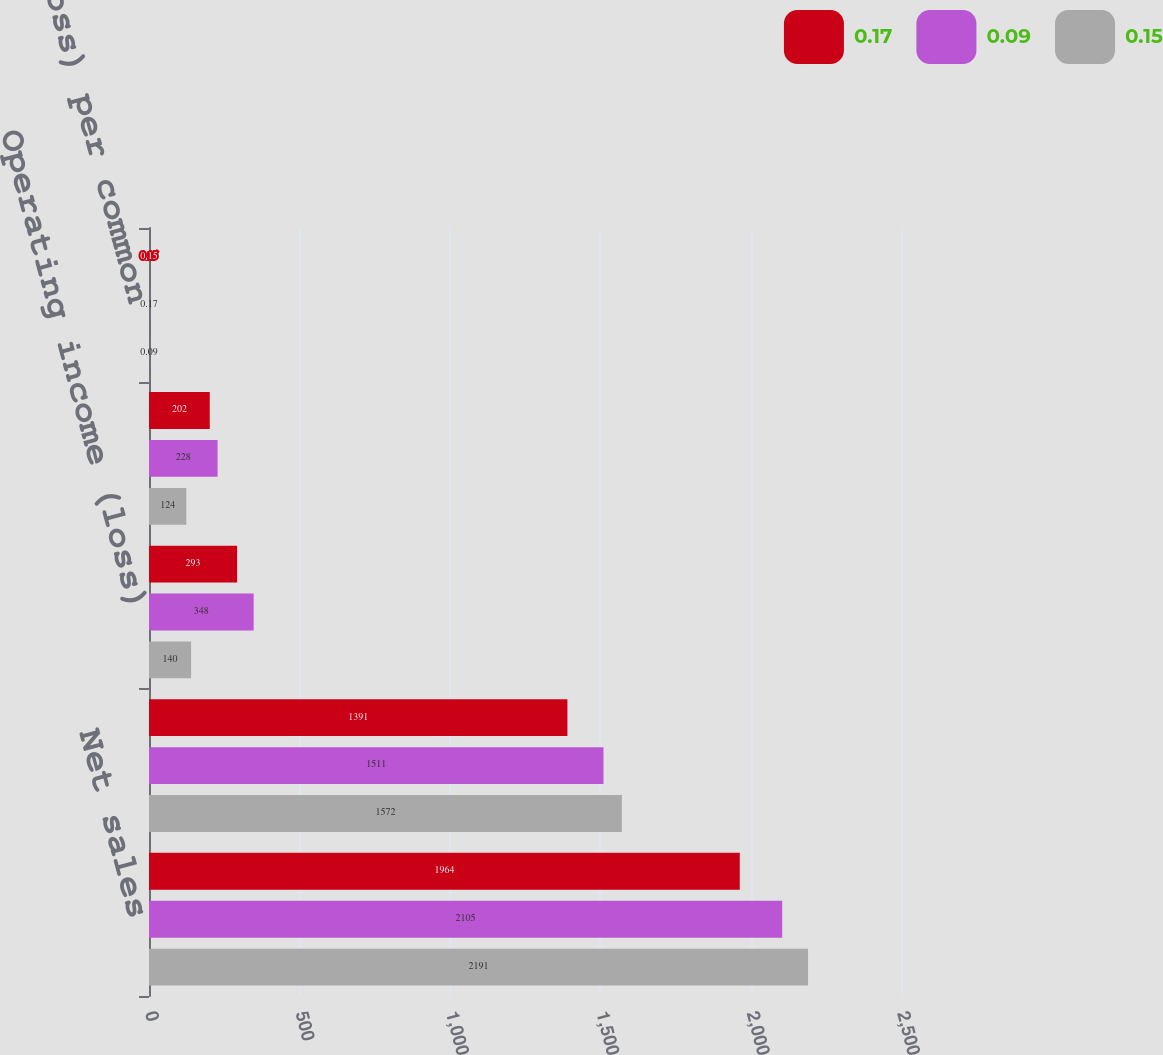Convert chart to OTSL. <chart><loc_0><loc_0><loc_500><loc_500><stacked_bar_chart><ecel><fcel>Net sales<fcel>Gross profit<fcel>Operating income (loss)<fcel>Net income (loss)<fcel>Net income (loss) per common<nl><fcel>0.17<fcel>1964<fcel>1391<fcel>293<fcel>202<fcel>0.15<nl><fcel>0.09<fcel>2105<fcel>1511<fcel>348<fcel>228<fcel>0.17<nl><fcel>0.15<fcel>2191<fcel>1572<fcel>140<fcel>124<fcel>0.09<nl></chart> 